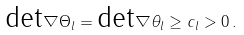<formula> <loc_0><loc_0><loc_500><loc_500>\text {det} \nabla \Theta _ { l } = \text {det} \nabla \theta _ { l } \geq c _ { l } > 0 \, .</formula> 